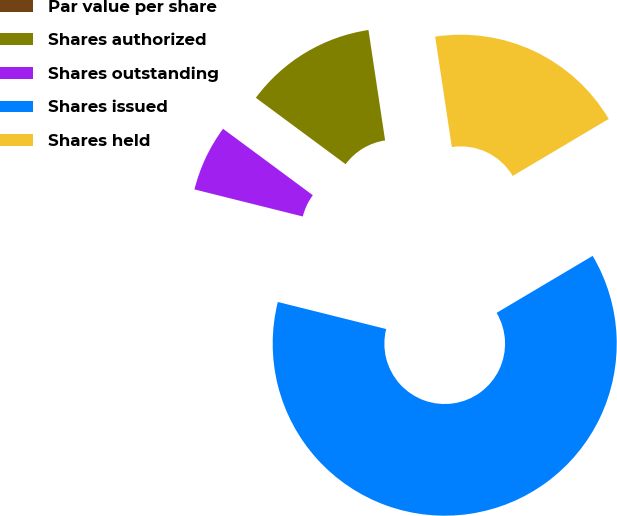Convert chart to OTSL. <chart><loc_0><loc_0><loc_500><loc_500><pie_chart><fcel>Par value per share<fcel>Shares authorized<fcel>Shares outstanding<fcel>Shares issued<fcel>Shares held<nl><fcel>0.0%<fcel>12.48%<fcel>6.24%<fcel>62.42%<fcel>18.86%<nl></chart> 